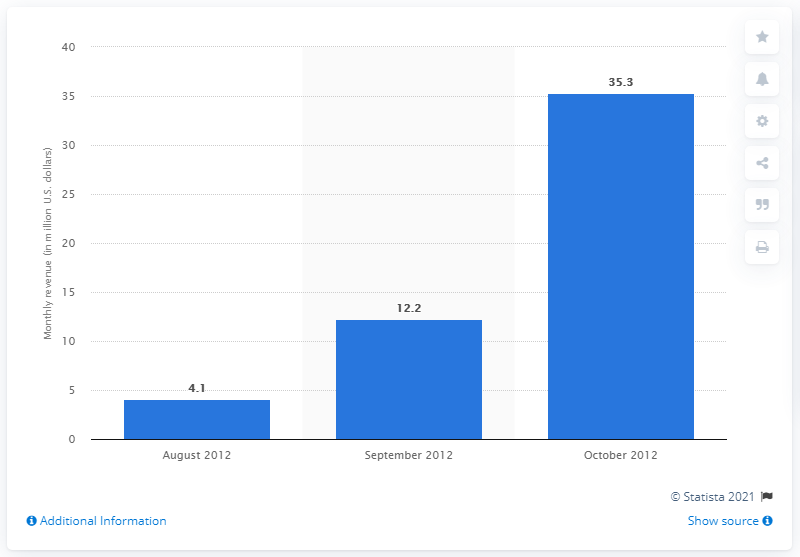Point out several critical features in this image. In October 2012, Kakao Games generated 35.3 million in revenue. Kakao Game was launched in August 2012. 